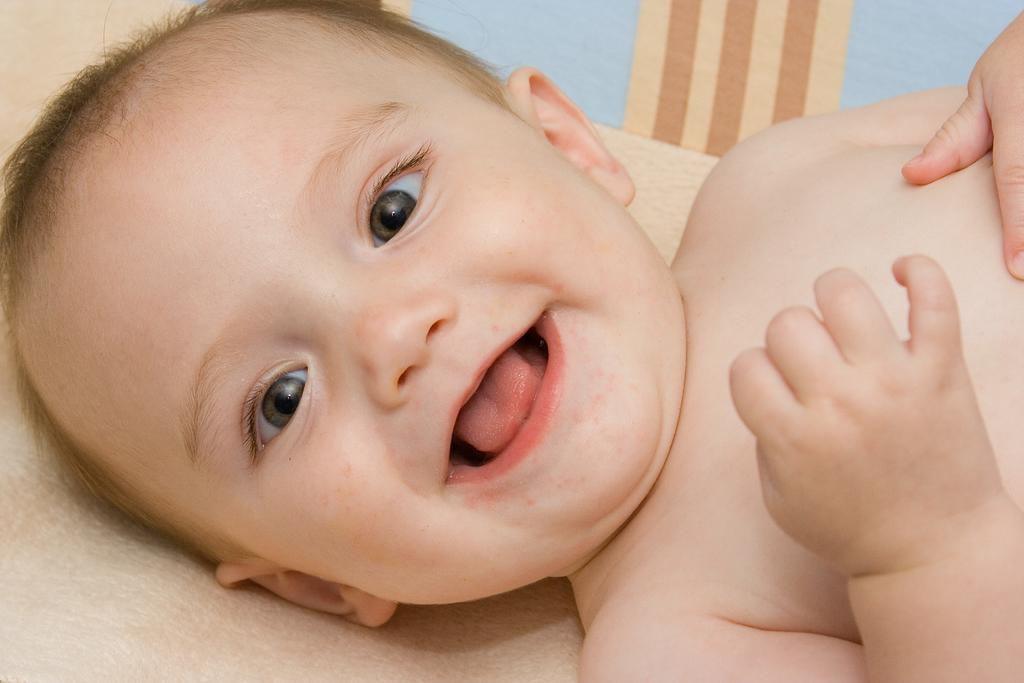What is the main subject of the image? There is a child in the image. What is the child doing in the image? The child is lying down and smiling. What can be seen at the bottom of the image? There is a cloth at the bottom of the image. What type of stick is the child holding in the image? There is no stick present in the image; the child is not holding anything. What color is the flesh of the robin in the image? There is no robin present in the image, so it is not possible to determine the color of its flesh. 